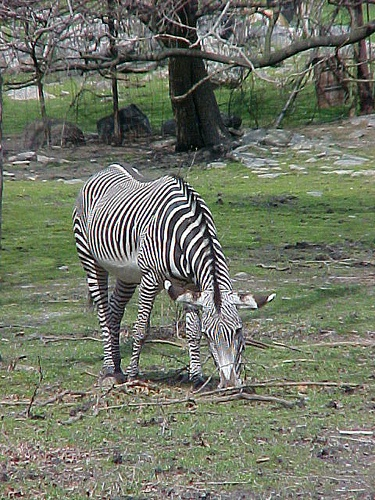Describe the objects in this image and their specific colors. I can see a zebra in gray, white, black, and darkgray tones in this image. 